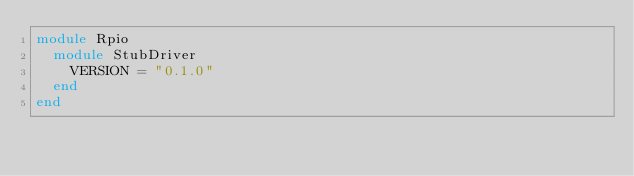<code> <loc_0><loc_0><loc_500><loc_500><_Ruby_>module Rpio
  module StubDriver
    VERSION = "0.1.0"
  end
end
</code> 